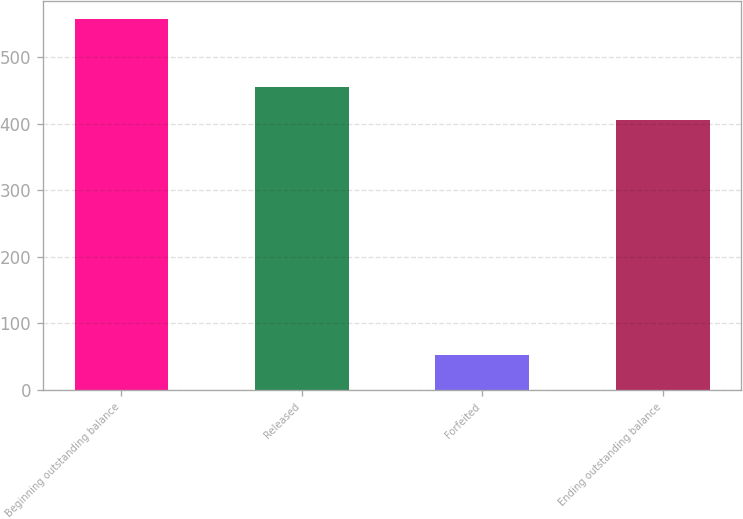Convert chart to OTSL. <chart><loc_0><loc_0><loc_500><loc_500><bar_chart><fcel>Beginning outstanding balance<fcel>Released<fcel>Forfeited<fcel>Ending outstanding balance<nl><fcel>557<fcel>455.4<fcel>53<fcel>405<nl></chart> 